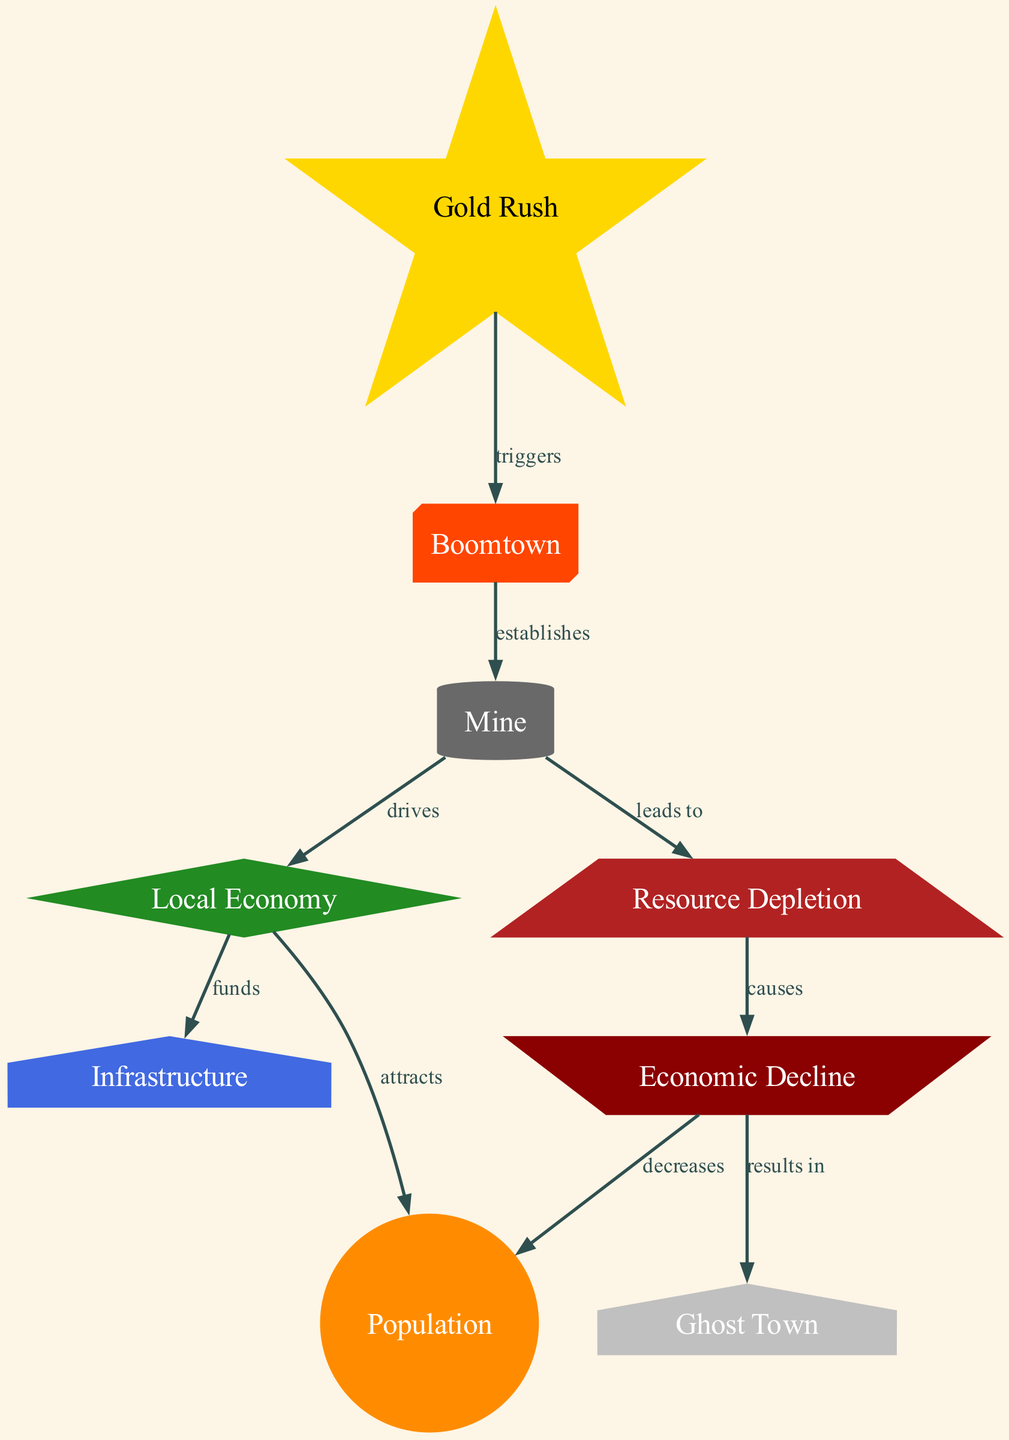What node is triggered by the Gold Rush? The diagram shows a directed edge from "Gold Rush" to "Boomtown," indicating that the Gold Rush is the starting event that triggers the formation of a Boomtown.
Answer: Boomtown What does a Boomtown establish? The directed edge from "Boomtown" to "Mine" indicates that a Boomtown establishes a Mine as part of its development.
Answer: Mine How does the Mine affect the Local Economy? The directed edge from "Mine" to "Local Economy" shows that the Mine drives the Local Economy, meaning it plays a crucial role in its growth and sustenance.
Answer: Drives Which node results from Economic Decline? The directed edge from "Economic Decline" to "Ghost Town" indicates that the final outcome or result of an Economic Decline is the transformation into a Ghost Town.
Answer: Ghost Town What does Resource Depletion cause? The edge from "Resource Depletion" to "Economic Decline" indicates that Resource Depletion causes an Economic Decline, suggesting that the depletion of resources negatively impacts the economy of the town.
Answer: Economic Decline How many total nodes are in the diagram? Counting the nodes listed in the provided data, there are a total of 9 nodes present in the diagram, representing different stages or aspects of the mining town lifecycle.
Answer: 9 What relationship allows the Local Economy to attract the Population? The directed edge from "Local Economy" to "Population" labeled "attracts" shows that the growth and prosperity of the Local Economy are responsible for attracting more population to the area.
Answer: Attracts Which stage leads to Resource Depletion? The edge from "Mine" to "Resource Depletion" highlights that the operation of the Mine leads to Resource Depletion, indicating the cycle of resource utilization.
Answer: Leads to What node is directly affected by Economic Decline? The directed edge from "Economic Decline" to "Population" indicates that Economic Decline directly decreases the Population in the mining town.
Answer: Decreases 